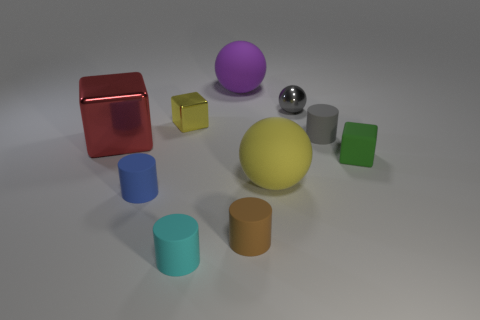Subtract all small gray rubber cylinders. How many cylinders are left? 3 Subtract all blue cylinders. How many cylinders are left? 3 Subtract all yellow blocks. Subtract all cyan cylinders. How many blocks are left? 2 Subtract all blue cylinders. How many yellow spheres are left? 1 Subtract all brown objects. Subtract all rubber cylinders. How many objects are left? 5 Add 4 tiny rubber objects. How many tiny rubber objects are left? 9 Add 9 red metal cubes. How many red metal cubes exist? 10 Subtract 0 purple cylinders. How many objects are left? 10 Subtract all cylinders. How many objects are left? 6 